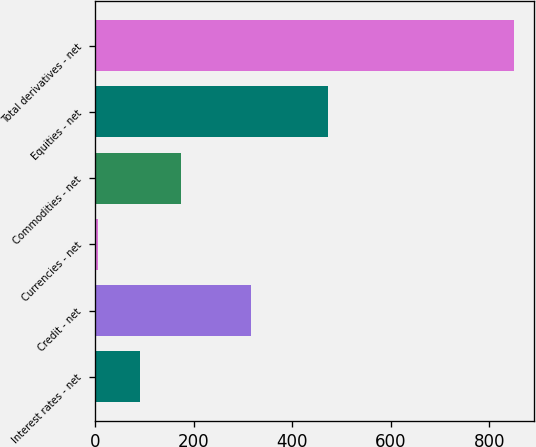Convert chart. <chart><loc_0><loc_0><loc_500><loc_500><bar_chart><fcel>Interest rates - net<fcel>Credit - net<fcel>Currencies - net<fcel>Commodities - net<fcel>Equities - net<fcel>Total derivatives - net<nl><fcel>90.3<fcel>315<fcel>6<fcel>174.6<fcel>472<fcel>849<nl></chart> 